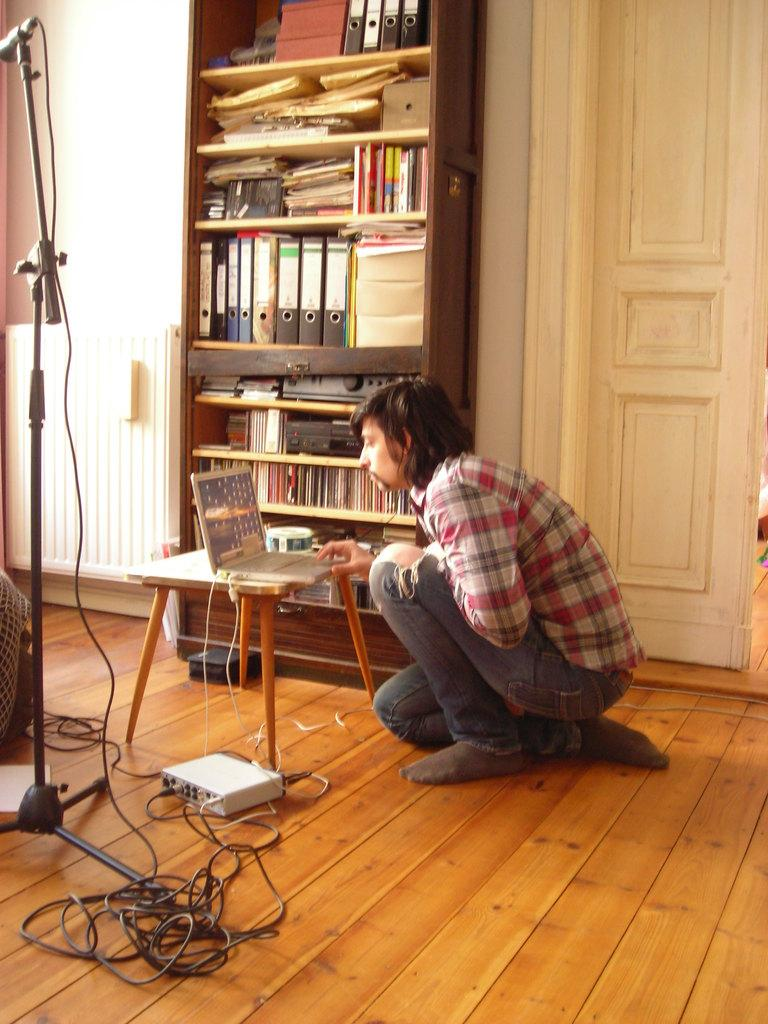What object is present in the image that is commonly used for amplifying sound? There is a microphone in the image. What items can be seen in the image that are typically used for learning or reading? There are books in the image. What piece of furniture is visible in the image that is often used for placing objects? There is a table in the image. What electronic device is present in the image that is commonly used for computing and internet access? There is a laptop in the image. What is the man in the image doing, and where is he located? The man is sitting on the floor in the image. What type of celery is being chopped on the table in the image? There is no celery present in the image; the table contains a laptop and other items. 